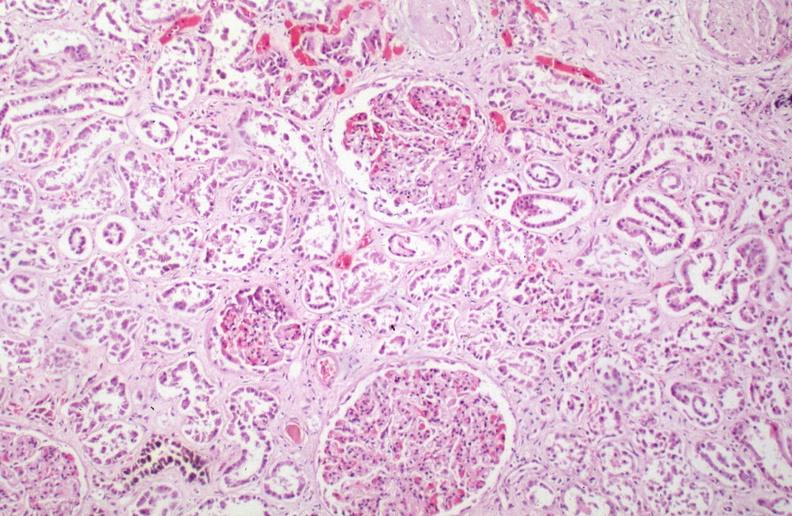how is hemosiderosis caused?
Answer the question using a single word or phrase. Numerous blood transfusions 